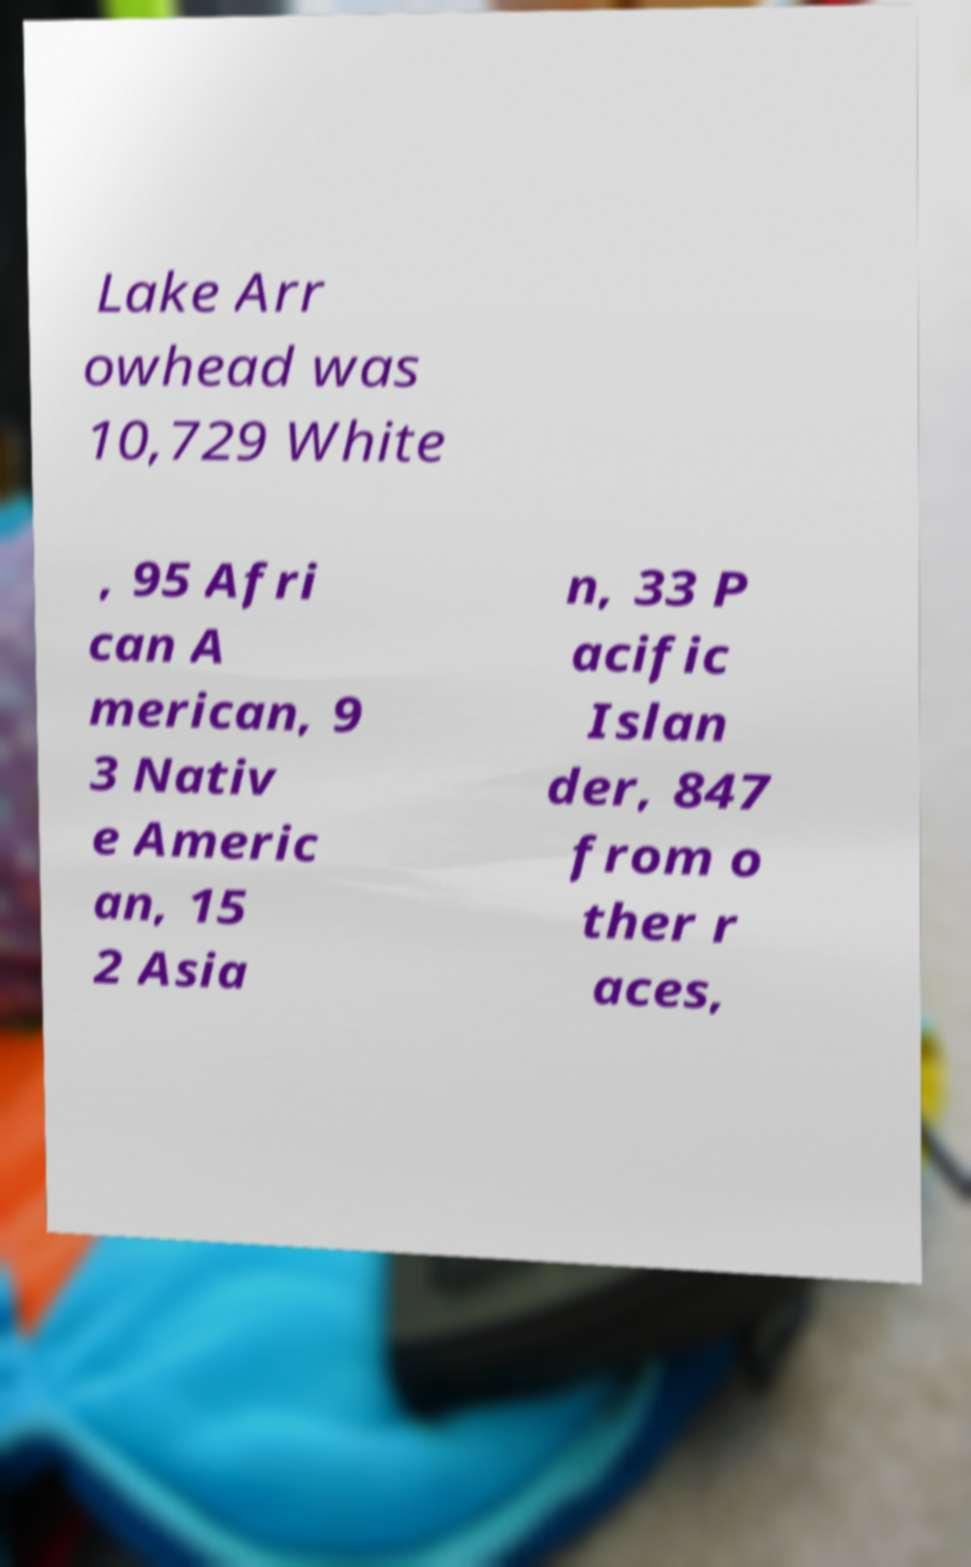Please read and relay the text visible in this image. What does it say? Lake Arr owhead was 10,729 White , 95 Afri can A merican, 9 3 Nativ e Americ an, 15 2 Asia n, 33 P acific Islan der, 847 from o ther r aces, 